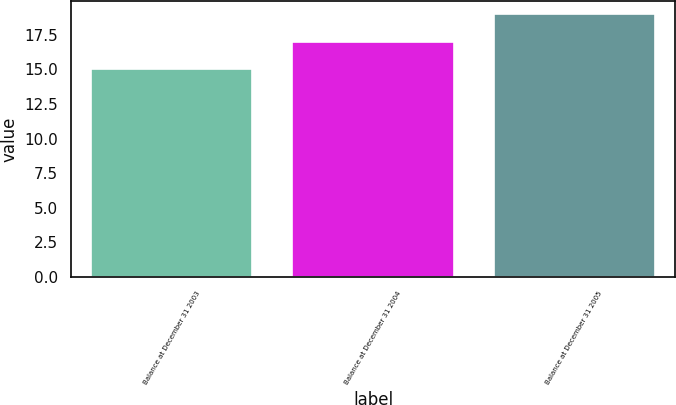Convert chart to OTSL. <chart><loc_0><loc_0><loc_500><loc_500><bar_chart><fcel>Balance at December 31 2003<fcel>Balance at December 31 2004<fcel>Balance at December 31 2005<nl><fcel>15<fcel>17<fcel>19<nl></chart> 